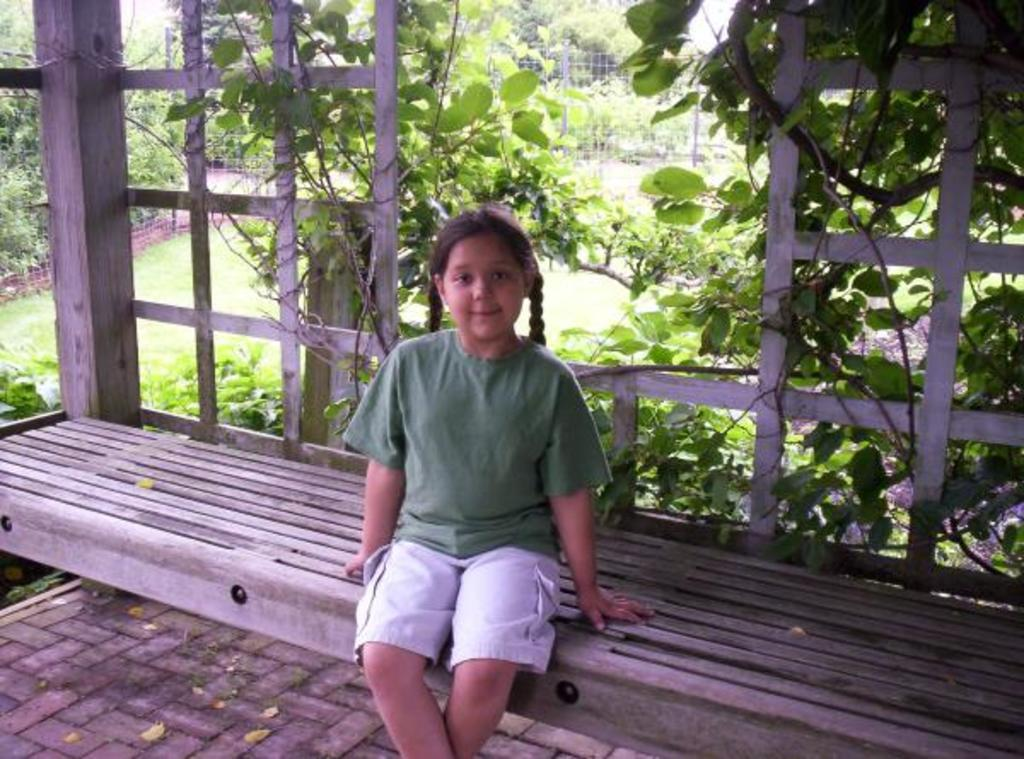What is the girl in the image doing? The girl is sitting on a bench and laughing. What can be seen behind the girl in the image? There are many trees behind the girl. What other elements are present in the image? There are creeps, plants, and an iron fence in the image. What type of advertisement can be seen on the girl's shirt in the image? There is no advertisement visible on the girl's shirt in the image. What competition is the girl participating in while sitting on the bench? There is no competition present in the image; the girl is simply sitting on a bench and laughing. 